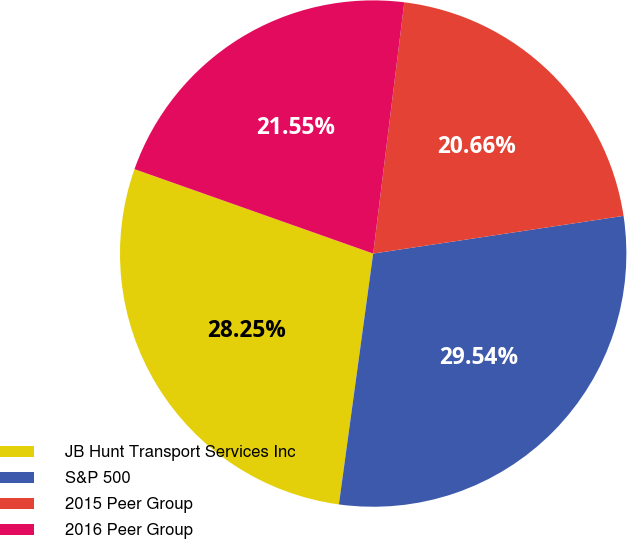Convert chart to OTSL. <chart><loc_0><loc_0><loc_500><loc_500><pie_chart><fcel>JB Hunt Transport Services Inc<fcel>S&P 500<fcel>2015 Peer Group<fcel>2016 Peer Group<nl><fcel>28.25%<fcel>29.54%<fcel>20.66%<fcel>21.55%<nl></chart> 